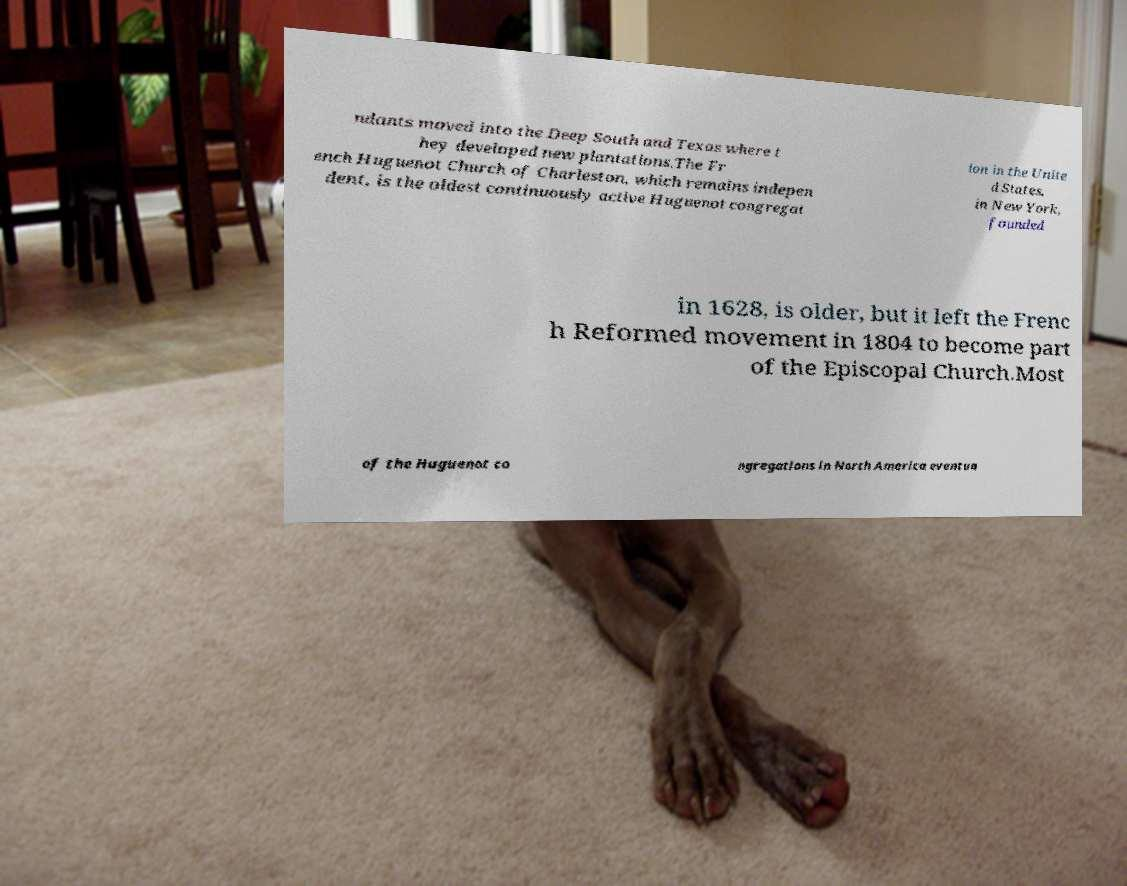For documentation purposes, I need the text within this image transcribed. Could you provide that? ndants moved into the Deep South and Texas where t hey developed new plantations.The Fr ench Huguenot Church of Charleston, which remains indepen dent, is the oldest continuously active Huguenot congregat ion in the Unite d States. in New York, founded in 1628, is older, but it left the Frenc h Reformed movement in 1804 to become part of the Episcopal Church.Most of the Huguenot co ngregations in North America eventua 